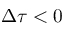<formula> <loc_0><loc_0><loc_500><loc_500>\Delta \tau < 0</formula> 